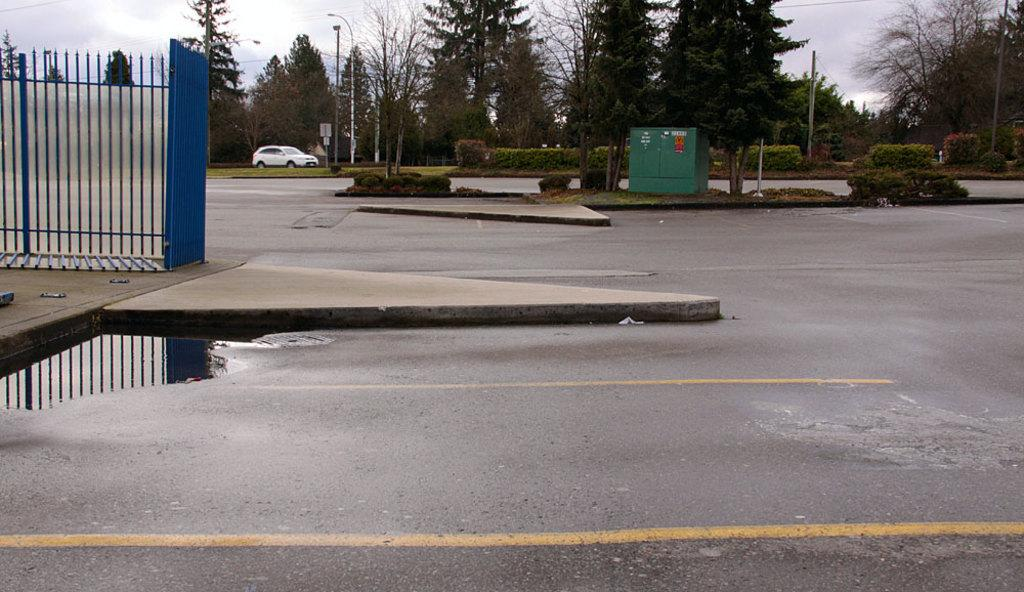What type of barrier can be seen in the image? There is a fence in the image. What type of pathway is present in the image? There is a road in the image. What type of natural elements are visible in the image? There are trees and plants in the image. What type of transportation is present in the image? There is a vehicle in the image. What type of structures are present in the image? There are light poles in the image. What other objects can be seen in the image? There are other objects in the image. What type of insurance is required for the vehicle in the image? The image does not provide information about the type of insurance required for the vehicle. What type of clouds can be seen in the image? There are no clouds visible in the image. 